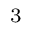<formula> <loc_0><loc_0><loc_500><loc_500>^ { 3 }</formula> 